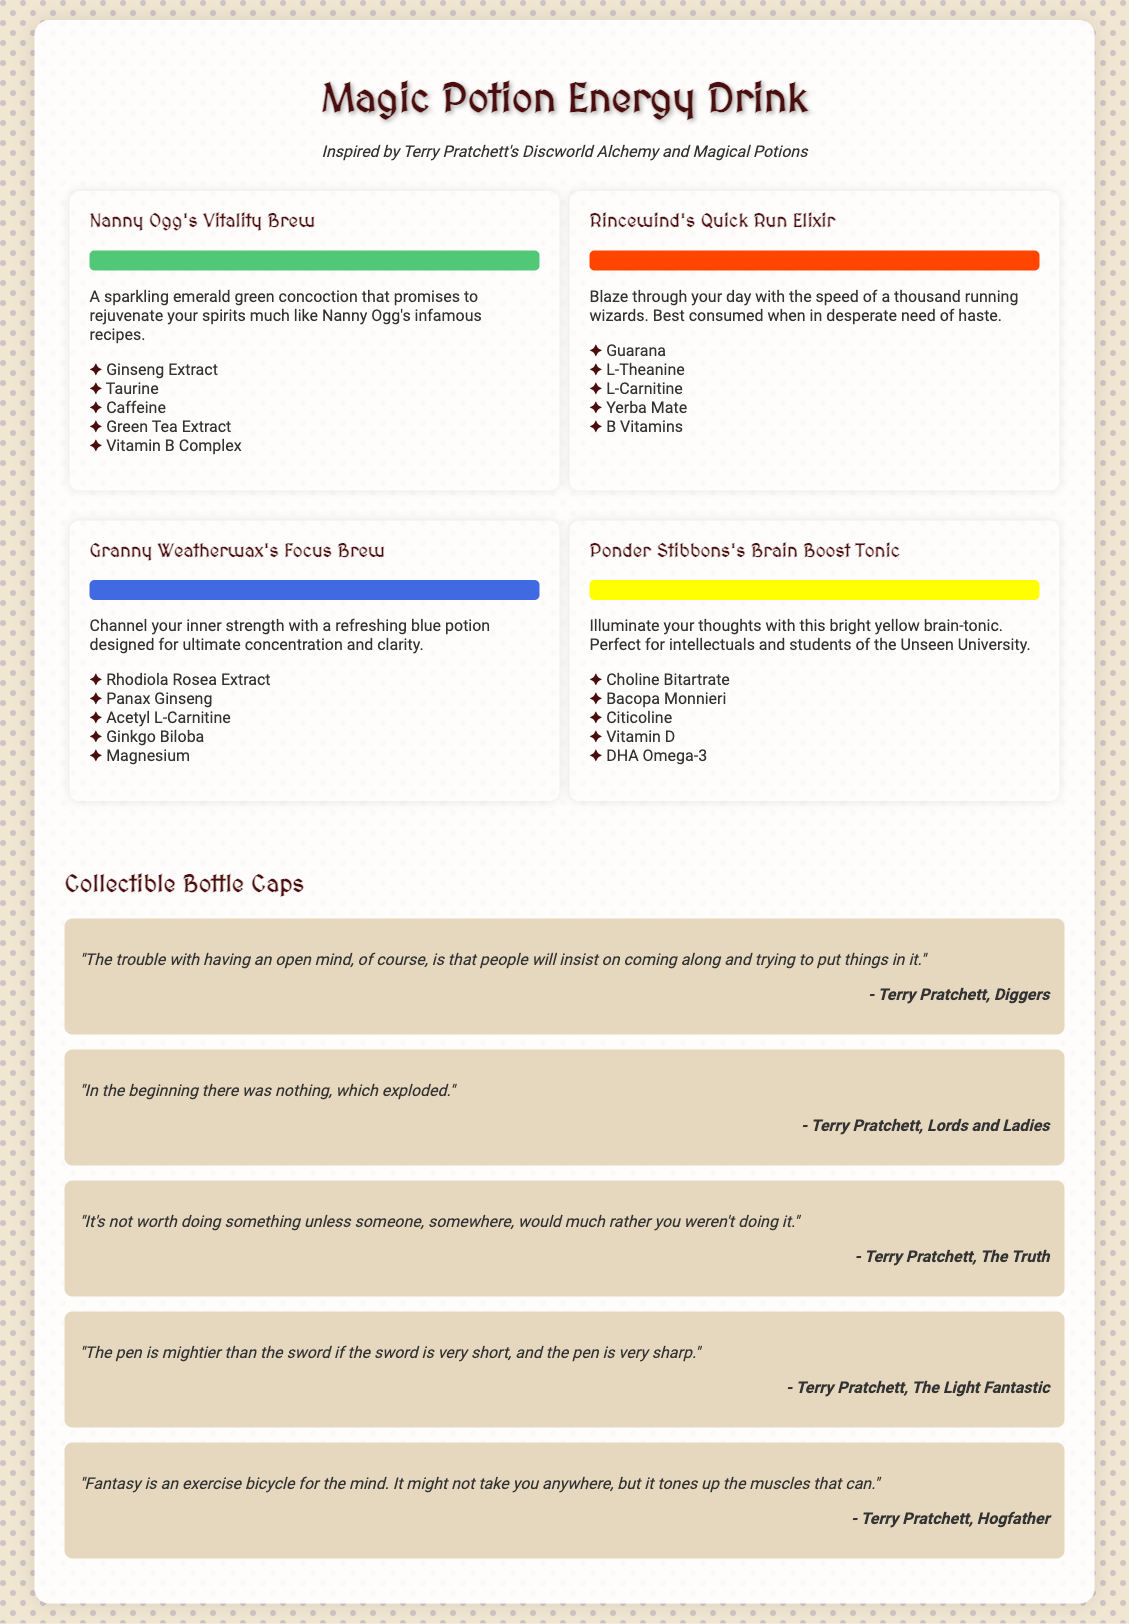What is the name of the first potion? The first potion listed is "Nanny Ogg's Vitality Brew."
Answer: Nanny Ogg's Vitality Brew What color is Rincewind's Quick Run Elixir? The potion is described with a blaze orange color.
Answer: Blaze orange How many ingredients are in Granny Weatherwax's Focus Brew? The document lists five ingredients for this potion.
Answer: 5 Which quote mentions an open mind? The quote about an open mind is: "The trouble with having an open mind, of course, is that people will insist on coming along and trying to put things in it."
Answer: An open mind What potion is aimed at intellectuals and students of the Unseen University? The potion specifically targeting intellectuals and students is "Ponder Stibbons's Brain Boost Tonic."
Answer: Ponder Stibbons's Brain Boost Tonic What is the main purpose of collectible bottle caps? The collectible bottle caps feature different quotes from Terry Pratchett's works.
Answer: Different quotes Which ingredient is found in Nanny Ogg's Vitality Brew? One of the ingredients listed is Ginseng Extract.
Answer: Ginseng Extract How many total potions are displayed in the document? There are four different potions showcased in the document.
Answer: 4 